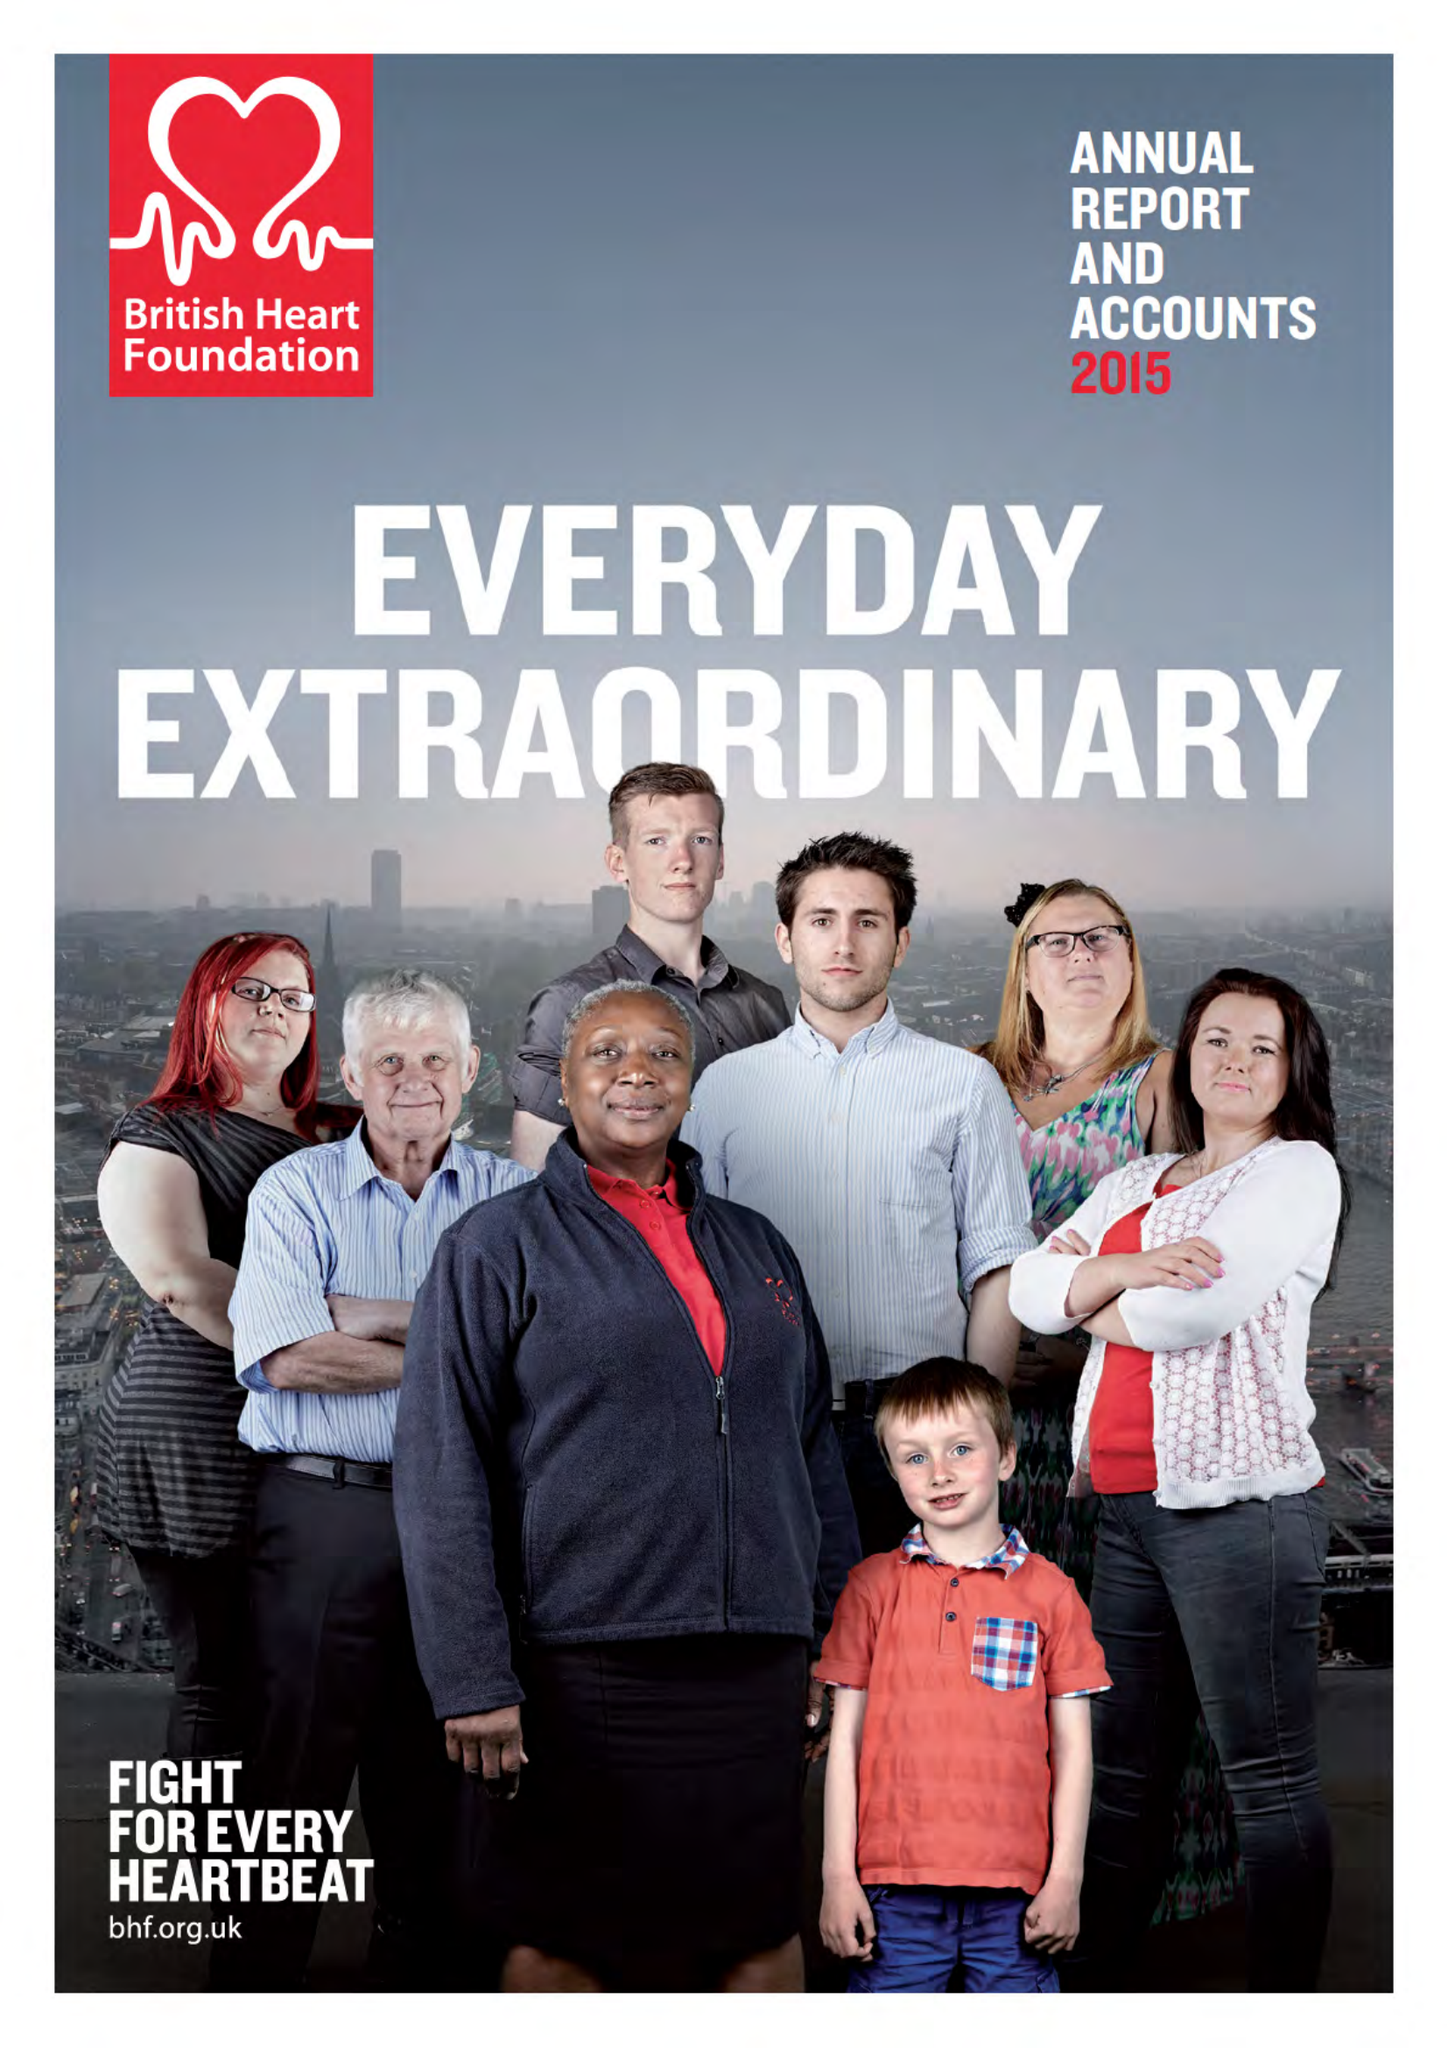What is the value for the charity_name?
Answer the question using a single word or phrase. British Heart Foundation 